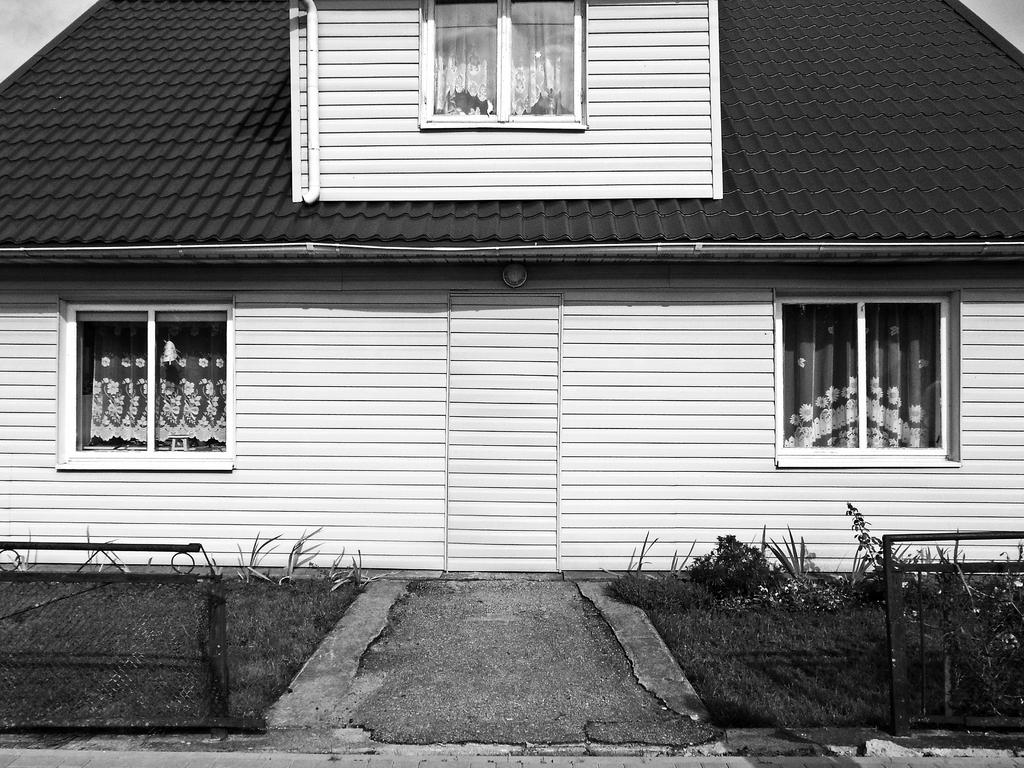What is the color scheme of the image? The image is black and white. What type of structure can be seen in the image? There is a house in the image. What is the purpose of the barrier in the image? There is a fence in the image, which serves as a barrier or boundary. What type of vegetation is present in the image? There are plants in the image. What is the ground made of in the image? The land is grassy in the image. What type of surface is visible in the image? There is a pavement in the image. How many passengers are waiting on the quicksand in the image? There is no quicksand or passengers present in the image. What type of laborer is working on the pavement in the image? There is no laborer present in the image, and the pavement does not show any ongoing work. 